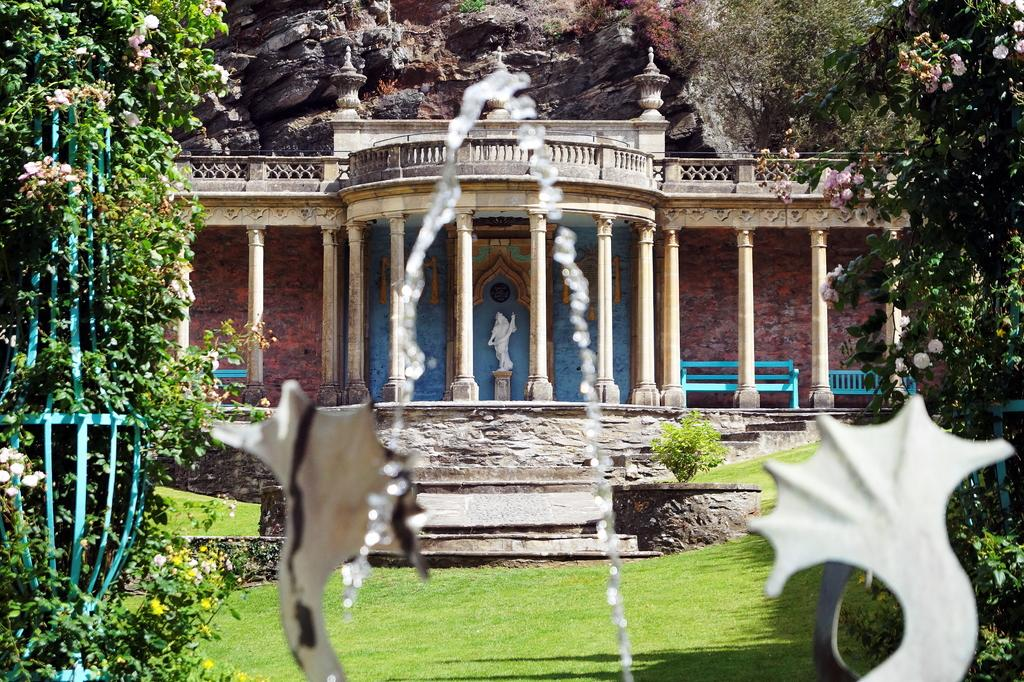What type of natural elements can be seen in the image? There are plants, trees, and flowers in the image. What type of man-made structures are present in the image? There is a temple and a sculpture in the image. What type of objects can be seen in the image that are made of metal? There are metal objects in the image. What type of seating is available in the image? There are benches in the image. What type of geological features can be seen in the image? There are rocks in the image. What type of liquid is visible in the image? There is water visible in the image. What type of spoon is being used to stir the water in the image? There is no spoon present in the image; it is not possible to stir the water with a spoon. 